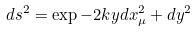Convert formula to latex. <formula><loc_0><loc_0><loc_500><loc_500>d s ^ { 2 } = \exp { - 2 k y } d x _ { \mu } ^ { 2 } + d y ^ { 2 }</formula> 